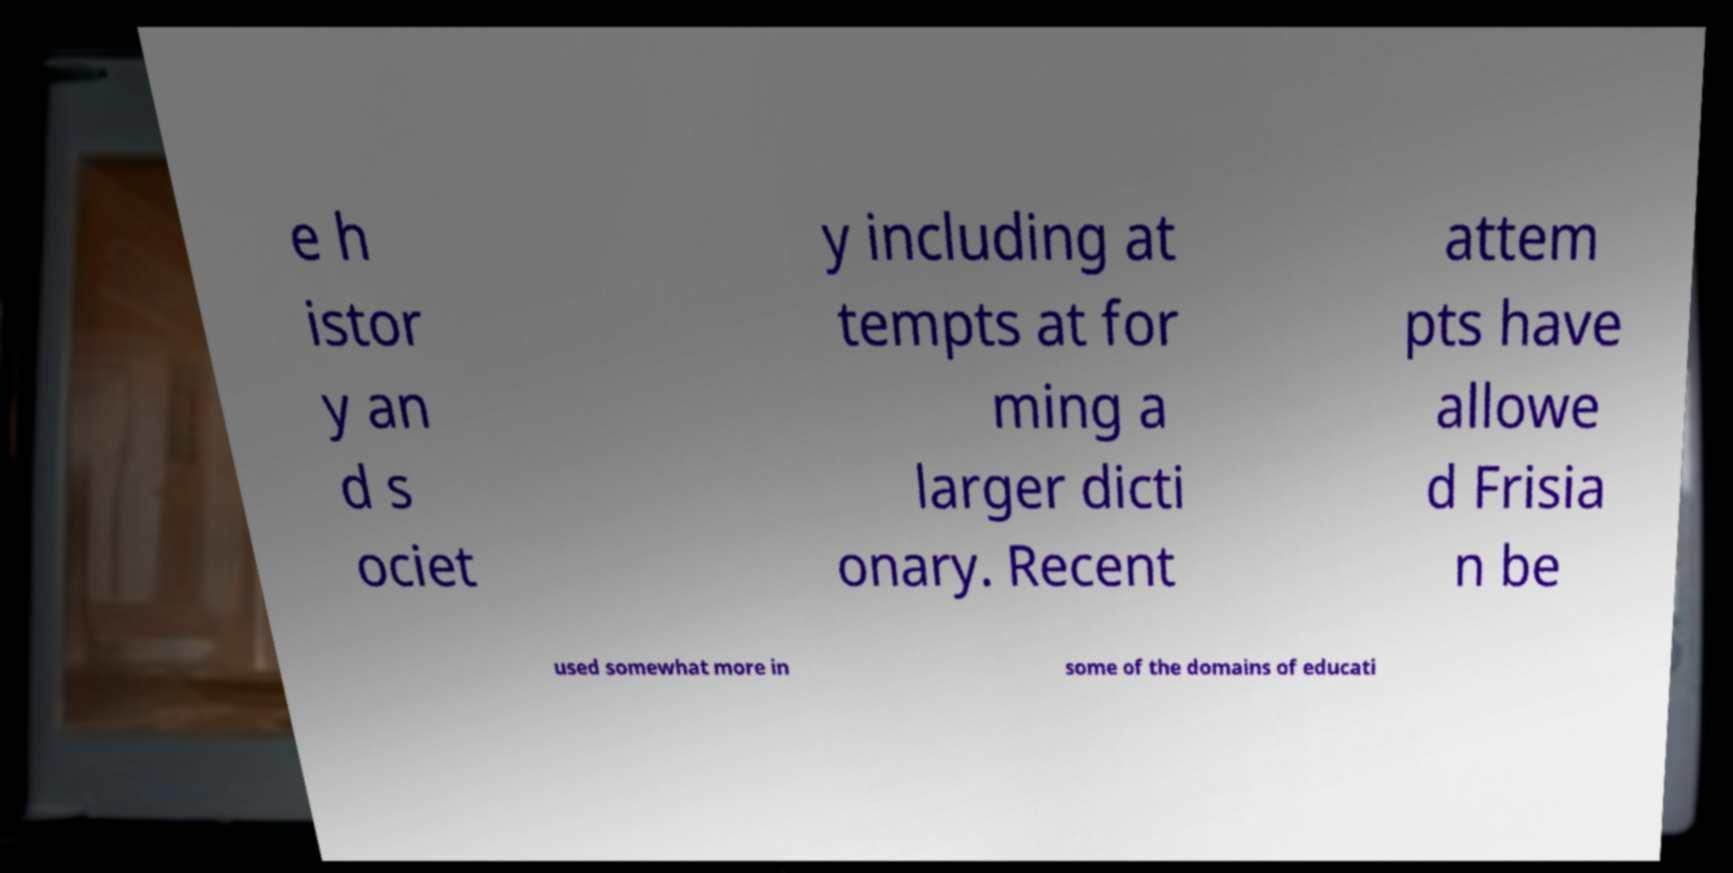Can you read and provide the text displayed in the image?This photo seems to have some interesting text. Can you extract and type it out for me? e h istor y an d s ociet y including at tempts at for ming a larger dicti onary. Recent attem pts have allowe d Frisia n be used somewhat more in some of the domains of educati 